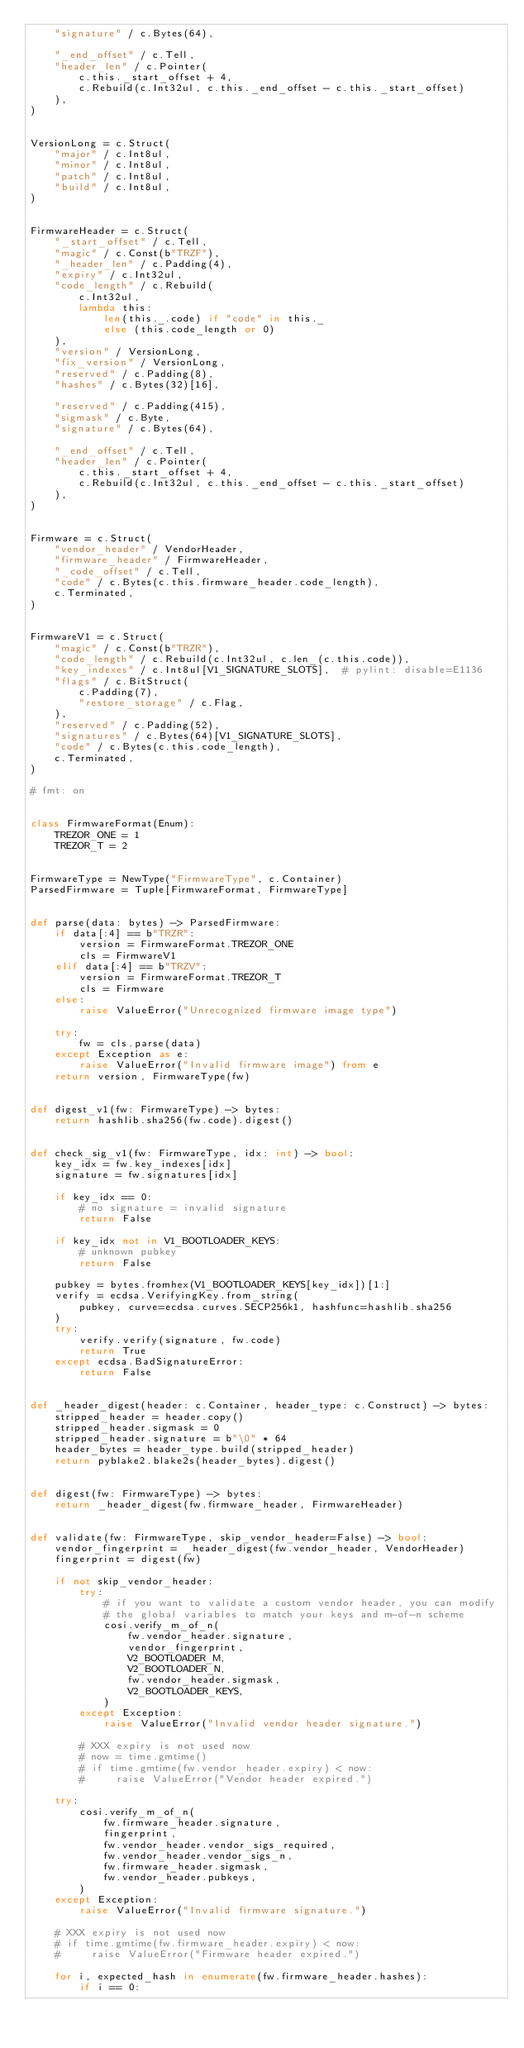<code> <loc_0><loc_0><loc_500><loc_500><_Python_>    "signature" / c.Bytes(64),

    "_end_offset" / c.Tell,
    "header_len" / c.Pointer(
        c.this._start_offset + 4,
        c.Rebuild(c.Int32ul, c.this._end_offset - c.this._start_offset)
    ),
)


VersionLong = c.Struct(
    "major" / c.Int8ul,
    "minor" / c.Int8ul,
    "patch" / c.Int8ul,
    "build" / c.Int8ul,
)


FirmwareHeader = c.Struct(
    "_start_offset" / c.Tell,
    "magic" / c.Const(b"TRZF"),
    "_header_len" / c.Padding(4),
    "expiry" / c.Int32ul,
    "code_length" / c.Rebuild(
        c.Int32ul,
        lambda this:
            len(this._.code) if "code" in this._
            else (this.code_length or 0)
    ),
    "version" / VersionLong,
    "fix_version" / VersionLong,
    "reserved" / c.Padding(8),
    "hashes" / c.Bytes(32)[16],

    "reserved" / c.Padding(415),
    "sigmask" / c.Byte,
    "signature" / c.Bytes(64),

    "_end_offset" / c.Tell,
    "header_len" / c.Pointer(
        c.this._start_offset + 4,
        c.Rebuild(c.Int32ul, c.this._end_offset - c.this._start_offset)
    ),
)


Firmware = c.Struct(
    "vendor_header" / VendorHeader,
    "firmware_header" / FirmwareHeader,
    "_code_offset" / c.Tell,
    "code" / c.Bytes(c.this.firmware_header.code_length),
    c.Terminated,
)


FirmwareV1 = c.Struct(
    "magic" / c.Const(b"TRZR"),
    "code_length" / c.Rebuild(c.Int32ul, c.len_(c.this.code)),
    "key_indexes" / c.Int8ul[V1_SIGNATURE_SLOTS],  # pylint: disable=E1136
    "flags" / c.BitStruct(
        c.Padding(7),
        "restore_storage" / c.Flag,
    ),
    "reserved" / c.Padding(52),
    "signatures" / c.Bytes(64)[V1_SIGNATURE_SLOTS],
    "code" / c.Bytes(c.this.code_length),
    c.Terminated,
)

# fmt: on


class FirmwareFormat(Enum):
    TREZOR_ONE = 1
    TREZOR_T = 2


FirmwareType = NewType("FirmwareType", c.Container)
ParsedFirmware = Tuple[FirmwareFormat, FirmwareType]


def parse(data: bytes) -> ParsedFirmware:
    if data[:4] == b"TRZR":
        version = FirmwareFormat.TREZOR_ONE
        cls = FirmwareV1
    elif data[:4] == b"TRZV":
        version = FirmwareFormat.TREZOR_T
        cls = Firmware
    else:
        raise ValueError("Unrecognized firmware image type")

    try:
        fw = cls.parse(data)
    except Exception as e:
        raise ValueError("Invalid firmware image") from e
    return version, FirmwareType(fw)


def digest_v1(fw: FirmwareType) -> bytes:
    return hashlib.sha256(fw.code).digest()


def check_sig_v1(fw: FirmwareType, idx: int) -> bool:
    key_idx = fw.key_indexes[idx]
    signature = fw.signatures[idx]

    if key_idx == 0:
        # no signature = invalid signature
        return False

    if key_idx not in V1_BOOTLOADER_KEYS:
        # unknown pubkey
        return False

    pubkey = bytes.fromhex(V1_BOOTLOADER_KEYS[key_idx])[1:]
    verify = ecdsa.VerifyingKey.from_string(
        pubkey, curve=ecdsa.curves.SECP256k1, hashfunc=hashlib.sha256
    )
    try:
        verify.verify(signature, fw.code)
        return True
    except ecdsa.BadSignatureError:
        return False


def _header_digest(header: c.Container, header_type: c.Construct) -> bytes:
    stripped_header = header.copy()
    stripped_header.sigmask = 0
    stripped_header.signature = b"\0" * 64
    header_bytes = header_type.build(stripped_header)
    return pyblake2.blake2s(header_bytes).digest()


def digest(fw: FirmwareType) -> bytes:
    return _header_digest(fw.firmware_header, FirmwareHeader)


def validate(fw: FirmwareType, skip_vendor_header=False) -> bool:
    vendor_fingerprint = _header_digest(fw.vendor_header, VendorHeader)
    fingerprint = digest(fw)

    if not skip_vendor_header:
        try:
            # if you want to validate a custom vendor header, you can modify
            # the global variables to match your keys and m-of-n scheme
            cosi.verify_m_of_n(
                fw.vendor_header.signature,
                vendor_fingerprint,
                V2_BOOTLOADER_M,
                V2_BOOTLOADER_N,
                fw.vendor_header.sigmask,
                V2_BOOTLOADER_KEYS,
            )
        except Exception:
            raise ValueError("Invalid vendor header signature.")

        # XXX expiry is not used now
        # now = time.gmtime()
        # if time.gmtime(fw.vendor_header.expiry) < now:
        #     raise ValueError("Vendor header expired.")

    try:
        cosi.verify_m_of_n(
            fw.firmware_header.signature,
            fingerprint,
            fw.vendor_header.vendor_sigs_required,
            fw.vendor_header.vendor_sigs_n,
            fw.firmware_header.sigmask,
            fw.vendor_header.pubkeys,
        )
    except Exception:
        raise ValueError("Invalid firmware signature.")

    # XXX expiry is not used now
    # if time.gmtime(fw.firmware_header.expiry) < now:
    #     raise ValueError("Firmware header expired.")

    for i, expected_hash in enumerate(fw.firmware_header.hashes):
        if i == 0:</code> 